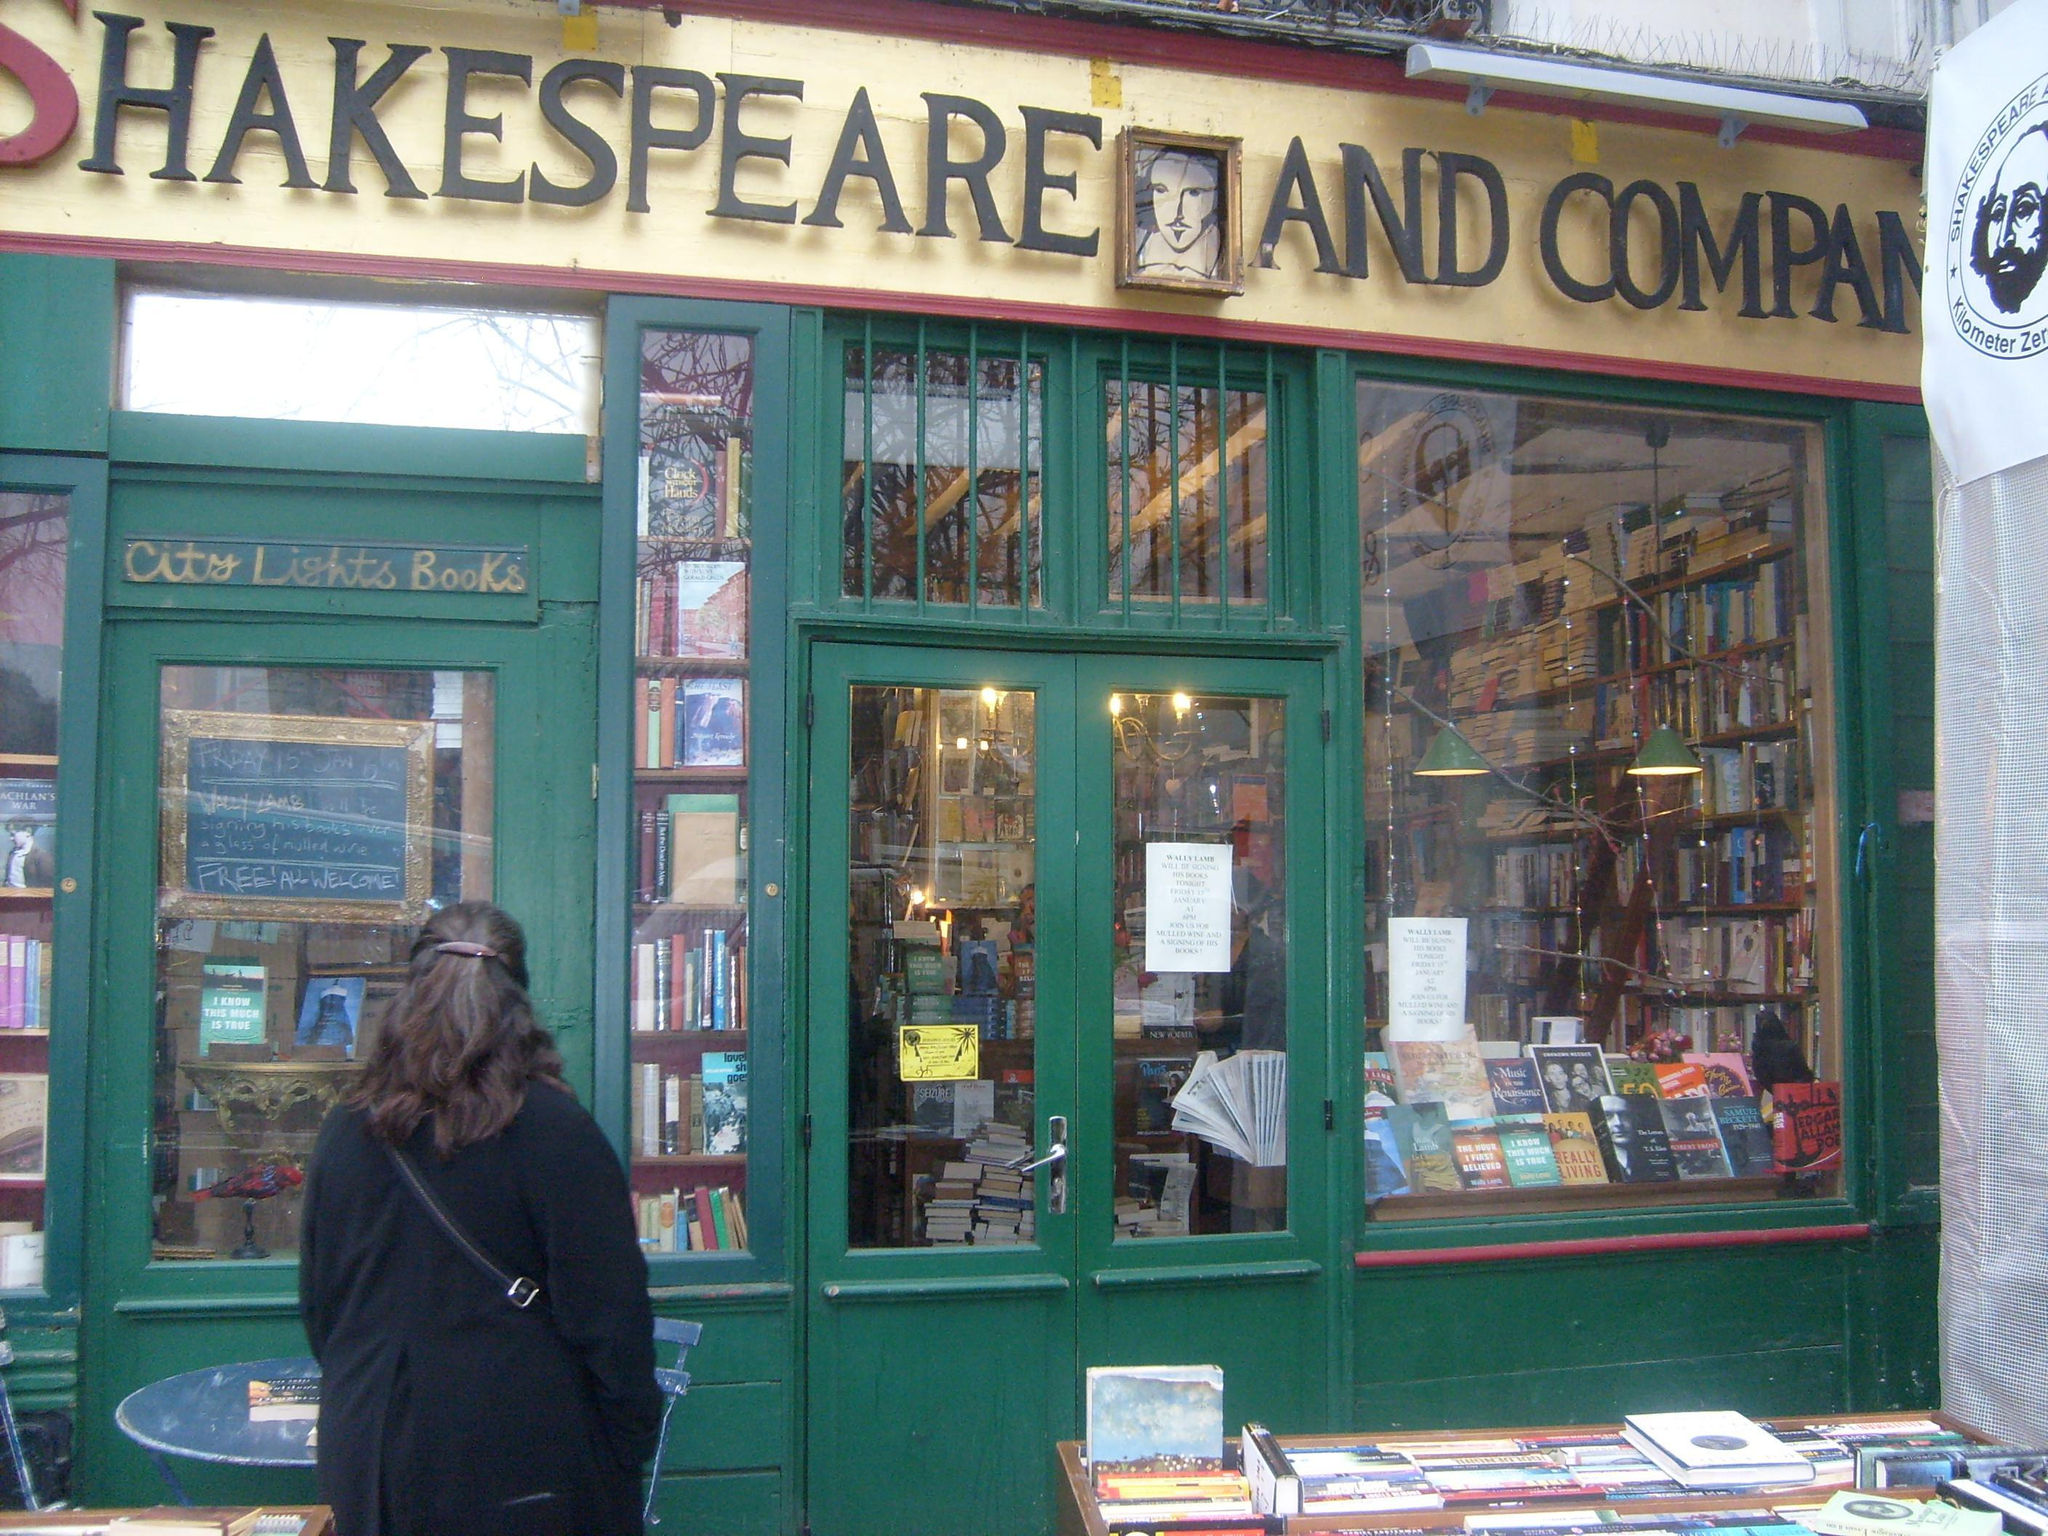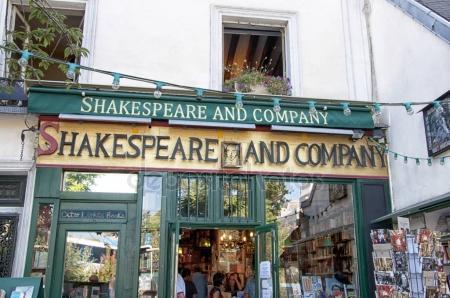The first image is the image on the left, the second image is the image on the right. Examine the images to the left and right. Is the description "There are people seated." accurate? Answer yes or no. No. The first image is the image on the left, the second image is the image on the right. Analyze the images presented: Is the assertion "People are seated outside in a shopping area." valid? Answer yes or no. No. 